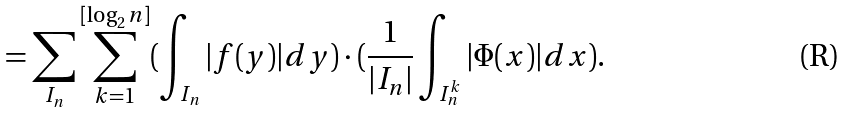<formula> <loc_0><loc_0><loc_500><loc_500>= \sum _ { I _ { n } } \sum _ { k = 1 } ^ { [ \log _ { 2 } n ] } ( \int _ { I _ { n } } | f ( y ) | d y ) \cdot ( \frac { 1 } { | I _ { n } | } \int _ { I _ { n } ^ { k } } | \Phi ( x ) | d x ) .</formula> 